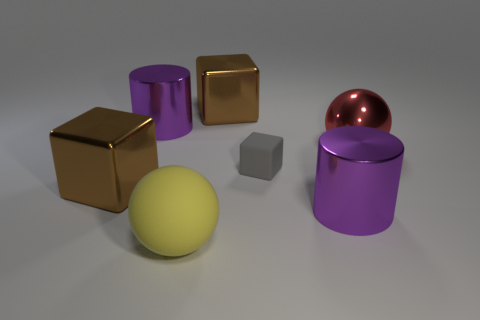There is a rubber object that is behind the large rubber thing; what size is it?
Offer a terse response. Small. Are there any other things that have the same color as the small rubber cube?
Keep it short and to the point. No. Is there a red thing behind the yellow sphere that is in front of the red object to the right of the small thing?
Provide a succinct answer. Yes. Is the color of the metal block behind the small block the same as the big shiny ball?
Your answer should be very brief. No. How many blocks are red things or big brown shiny things?
Offer a terse response. 2. What shape is the matte thing that is on the left side of the large brown block that is right of the big yellow matte ball?
Your answer should be compact. Sphere. There is a purple shiny cylinder that is behind the large purple metal thing in front of the shiny cube in front of the rubber block; what size is it?
Your answer should be compact. Large. Do the yellow ball and the gray matte thing have the same size?
Make the answer very short. No. How many things are red rubber spheres or metallic objects?
Your answer should be compact. 5. There is a brown shiny block that is on the right side of the brown object in front of the red metallic ball; how big is it?
Keep it short and to the point. Large. 